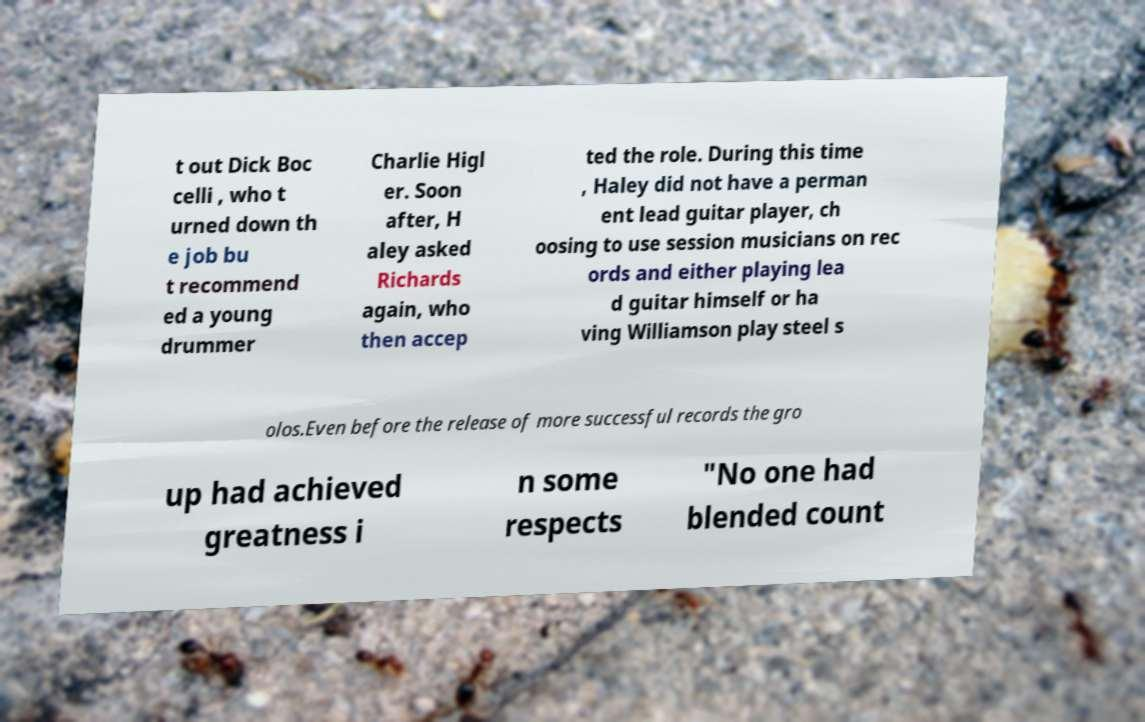Could you assist in decoding the text presented in this image and type it out clearly? t out Dick Boc celli , who t urned down th e job bu t recommend ed a young drummer Charlie Higl er. Soon after, H aley asked Richards again, who then accep ted the role. During this time , Haley did not have a perman ent lead guitar player, ch oosing to use session musicians on rec ords and either playing lea d guitar himself or ha ving Williamson play steel s olos.Even before the release of more successful records the gro up had achieved greatness i n some respects "No one had blended count 